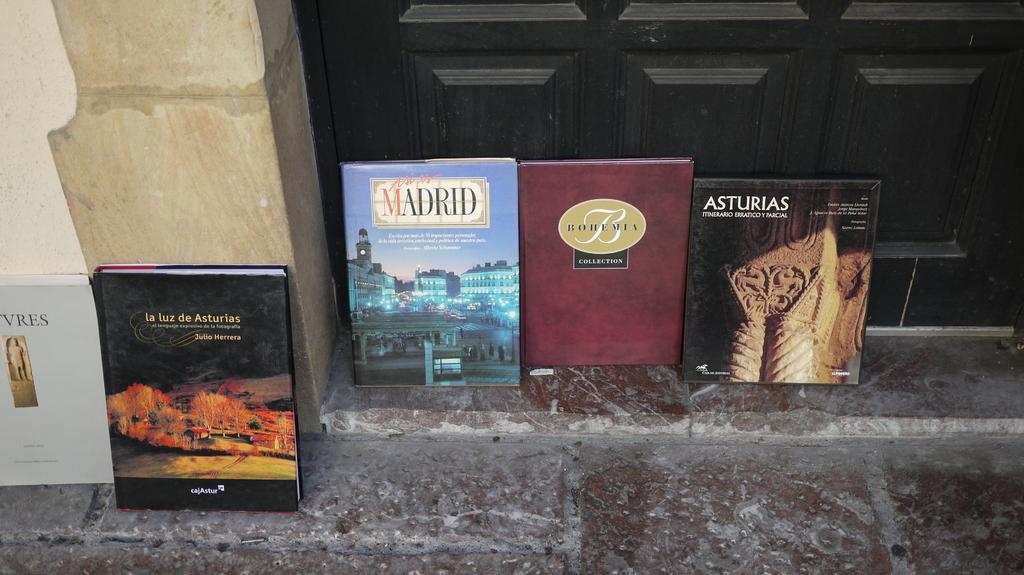<image>
Render a clear and concise summary of the photo. A book about Madrid sits with other books. 